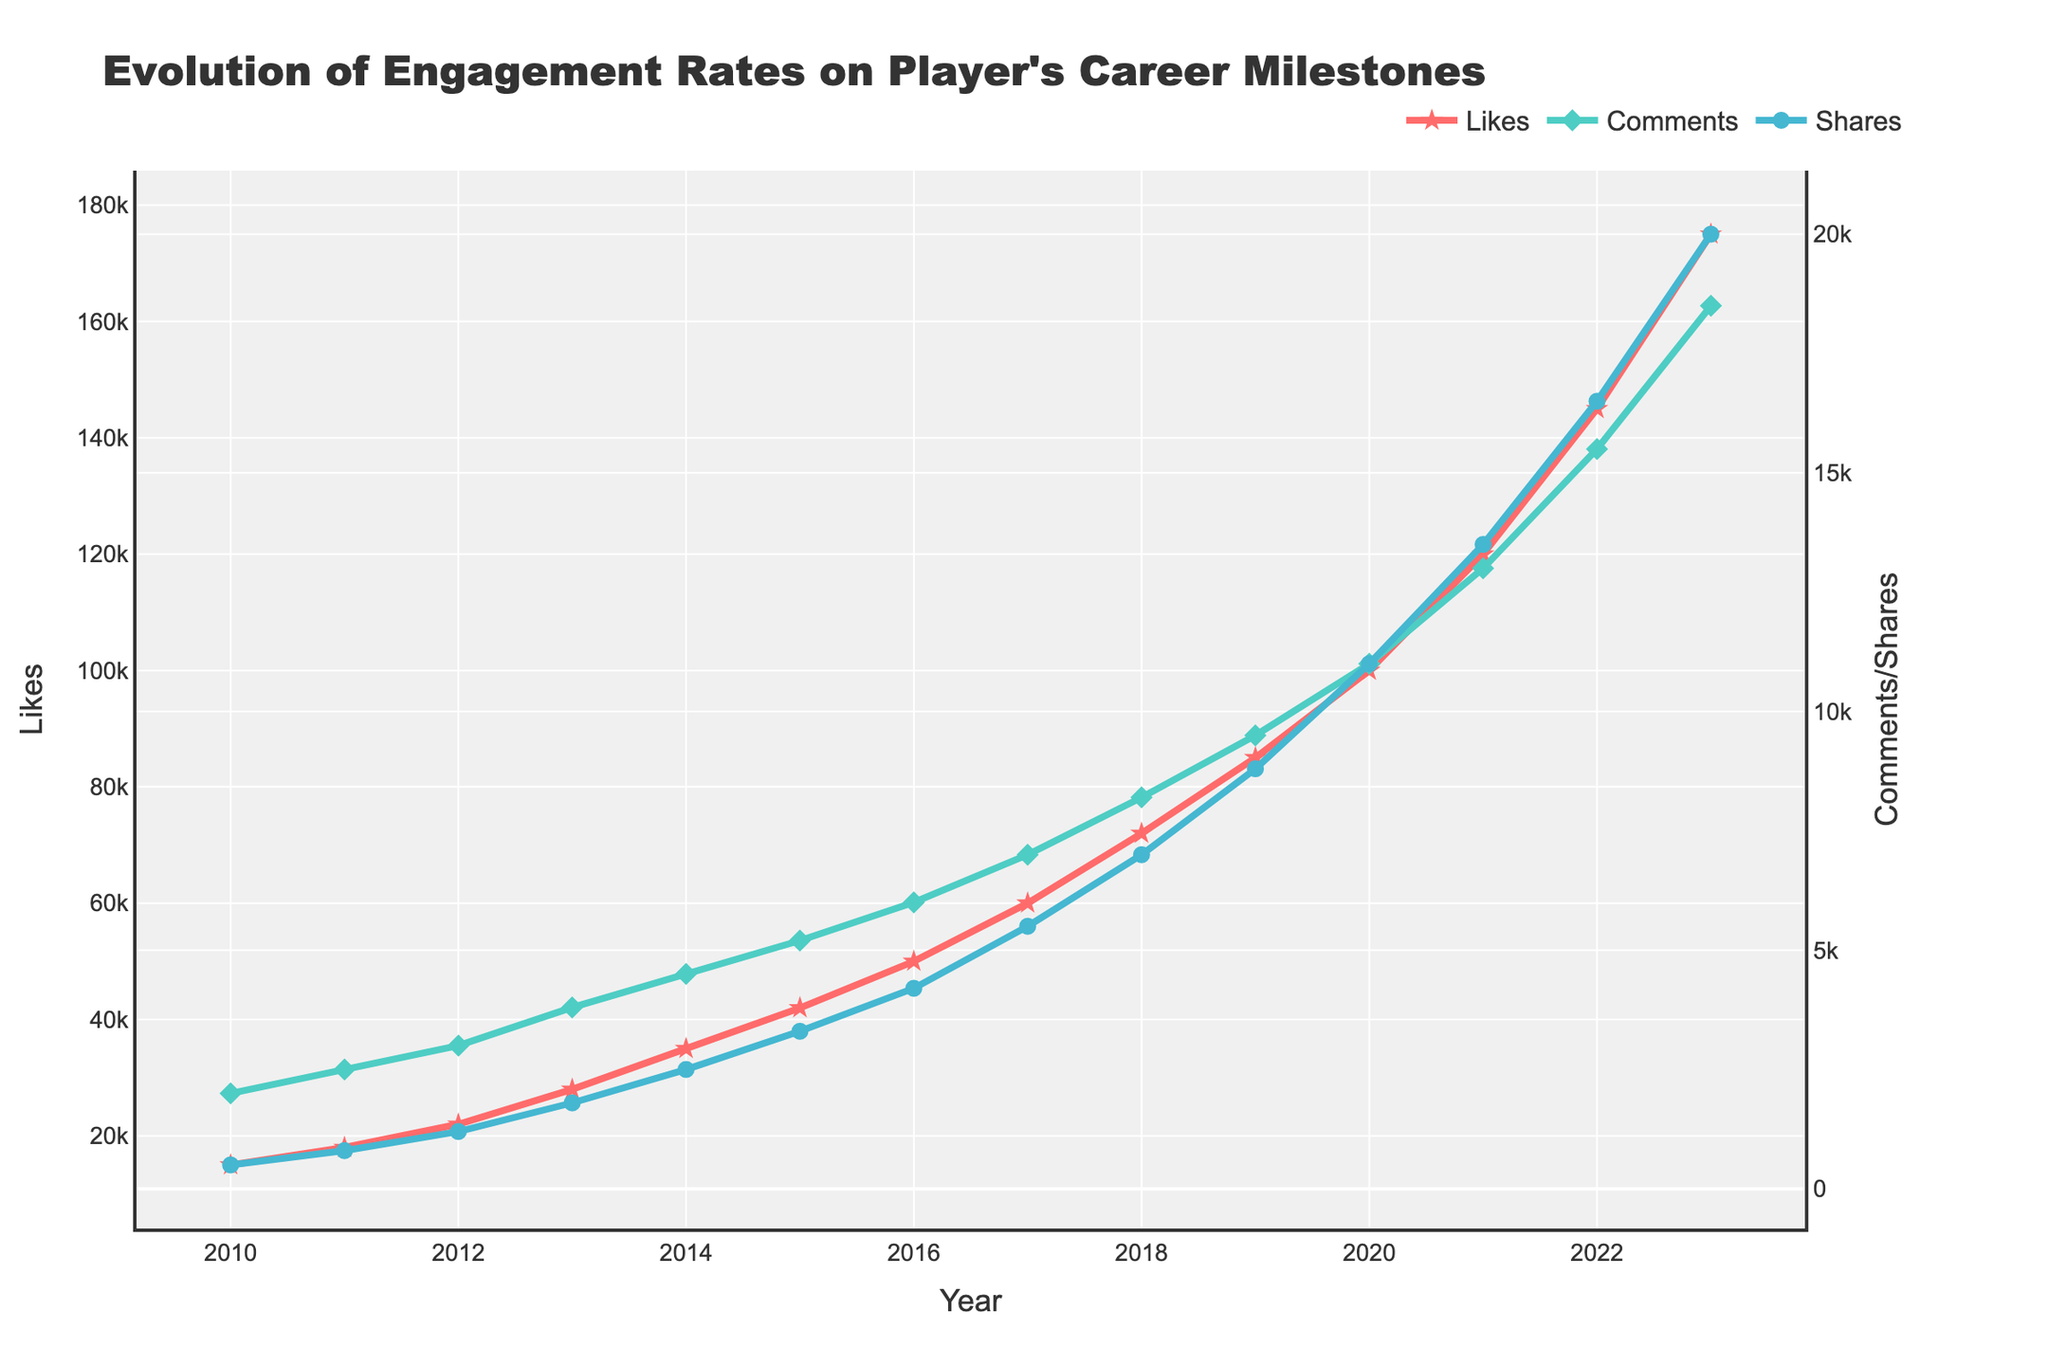What was the first year when the number of likes exceeded 50,000? By examining the trend line for likes, we see that it crosses the 50,000 mark in the year 2016.
Answer: 2016 Which year had the highest number of comments and what was the value? Looking at the peaks of the comments trend line, the highest point is in the year 2023 with 18,500 comments.
Answer: 2023, 18,500 Between 2012 and 2015, how much did the number of shares increase? The number of shares in 2012 was 1,200, and in 2015 it was 3,300. The increase is 3,300 - 1,200 = 2,100.
Answer: 2,100 Which line represents the values with a star marker? By examining the line markers, the star marker is used for likes.
Answer: Likes Compare the growth rate of likes and comments between 2020 and 2021. Which grew more, and by how much? In 2020, likes were 100,000 and comments were 11,000. In 2021, likes were 120,000 and comments were 13,000. The growth in likes is 120,000 - 100,000 = 20,000 and the growth in comments is 13,000 - 11,000 = 2,000. Likes grew by 18,000 more than comments.
Answer: Likes grew by 18,000 more In which year did the number of shares first exceed 10,000? By checking the shares trend line, we see it first exceeds 10,000 in 2020.
Answer: 2020 What is the total number of likes accumulated from 2010 to 2015? Sum the number of likes from 2010 to 2015: 15,000 + 18,000 + 22,000 + 28,000 + 35,000 + 42,000 = 160,000.
Answer: 160,000 Which color represents the shares trend line? The shares trend line is represented by the blue color.
Answer: Blue What is the average number of comments received per year from 2018 to 2023? Sum the number of comments from 2018 to 2023 and divide by the number of years: (8,200 + 9,500 + 11,000 + 13,000 + 15,500 + 18,500) / 6 = 12,283.33.
Answer: 12,283.33 By how much did the number of likes increase from 2010 to 2023? The number of likes in 2010 was 15,000 and in 2023 it was 175,000. The increase is 175,000 - 15,000 = 160,000.
Answer: 160,000 